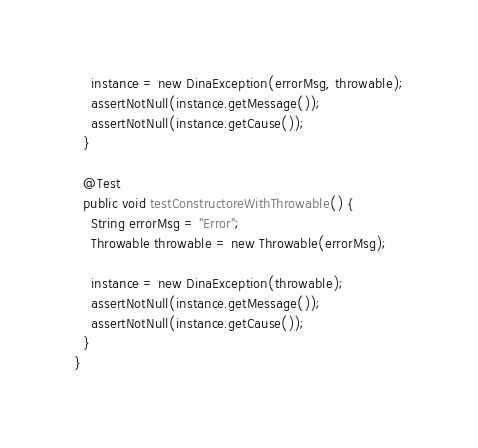Convert code to text. <code><loc_0><loc_0><loc_500><loc_500><_Java_>    instance = new DinaException(errorMsg, throwable);
    assertNotNull(instance.getMessage());
    assertNotNull(instance.getCause());
  } 
  
  @Test
  public void testConstructoreWithThrowable() {
    String errorMsg = "Error";
    Throwable throwable = new Throwable(errorMsg);
     
    instance = new DinaException(throwable);
    assertNotNull(instance.getMessage());
    assertNotNull(instance.getCause());
  } 
}
</code> 